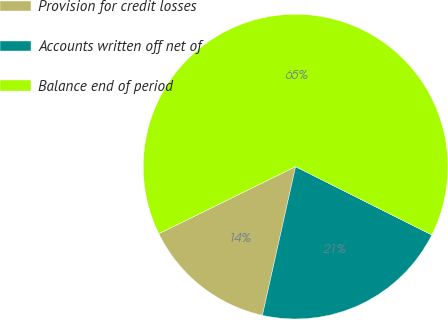<chart> <loc_0><loc_0><loc_500><loc_500><pie_chart><fcel>Provision for credit losses<fcel>Accounts written off net of<fcel>Balance end of period<nl><fcel>14.25%<fcel>21.1%<fcel>64.65%<nl></chart> 